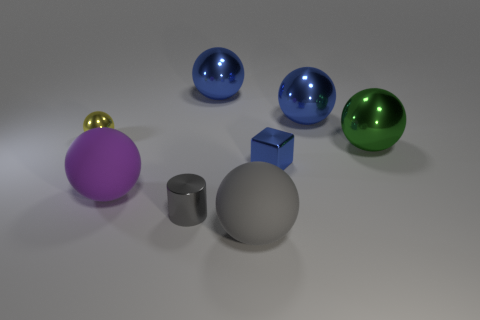The green metallic sphere is what size?
Offer a terse response. Large. What number of shiny spheres are left of the blue metal object that is in front of the large metallic ball that is in front of the yellow shiny sphere?
Your response must be concise. 2. There is a tiny thing that is behind the large shiny thing that is in front of the tiny yellow ball; what shape is it?
Make the answer very short. Sphere. There is a yellow shiny thing that is the same shape as the large green thing; what is its size?
Your answer should be compact. Small. Is there any other thing that is the same size as the cylinder?
Ensure brevity in your answer.  Yes. What color is the big metal sphere to the left of the tiny blue metal block?
Ensure brevity in your answer.  Blue. There is a gray object that is left of the blue ball that is behind the blue thing on the right side of the blue block; what is its material?
Your answer should be very brief. Metal. What size is the yellow ball to the left of the blue object that is in front of the yellow sphere?
Provide a short and direct response. Small. The tiny shiny object that is the same shape as the big green thing is what color?
Provide a short and direct response. Yellow. How many spheres have the same color as the tiny shiny cylinder?
Your response must be concise. 1. 